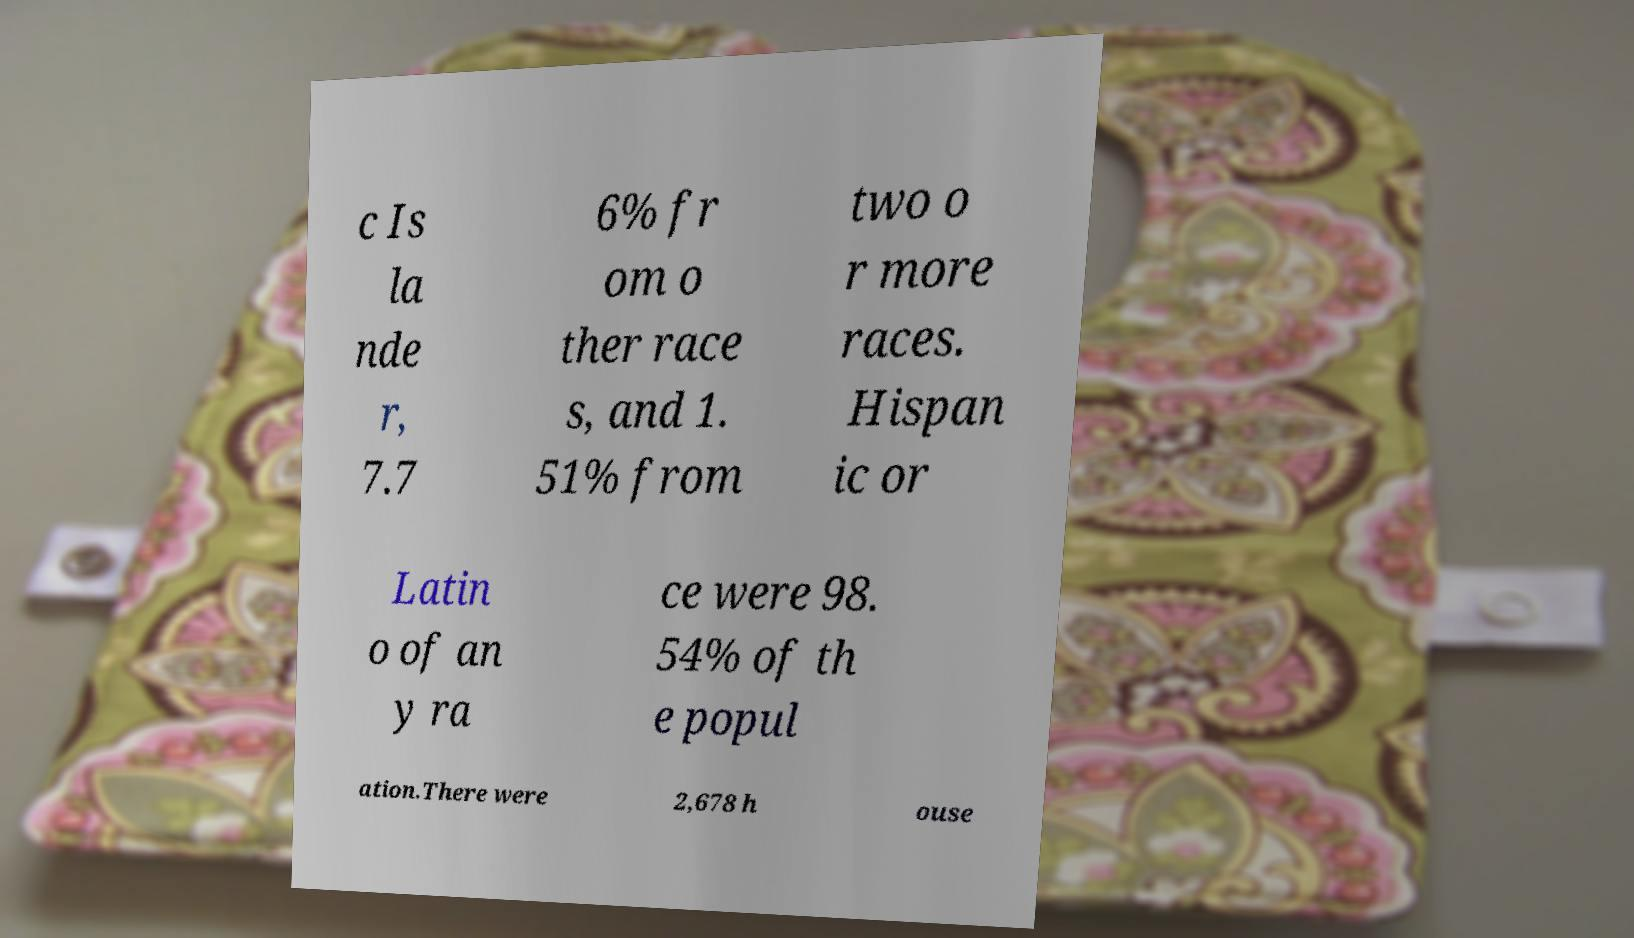There's text embedded in this image that I need extracted. Can you transcribe it verbatim? c Is la nde r, 7.7 6% fr om o ther race s, and 1. 51% from two o r more races. Hispan ic or Latin o of an y ra ce were 98. 54% of th e popul ation.There were 2,678 h ouse 